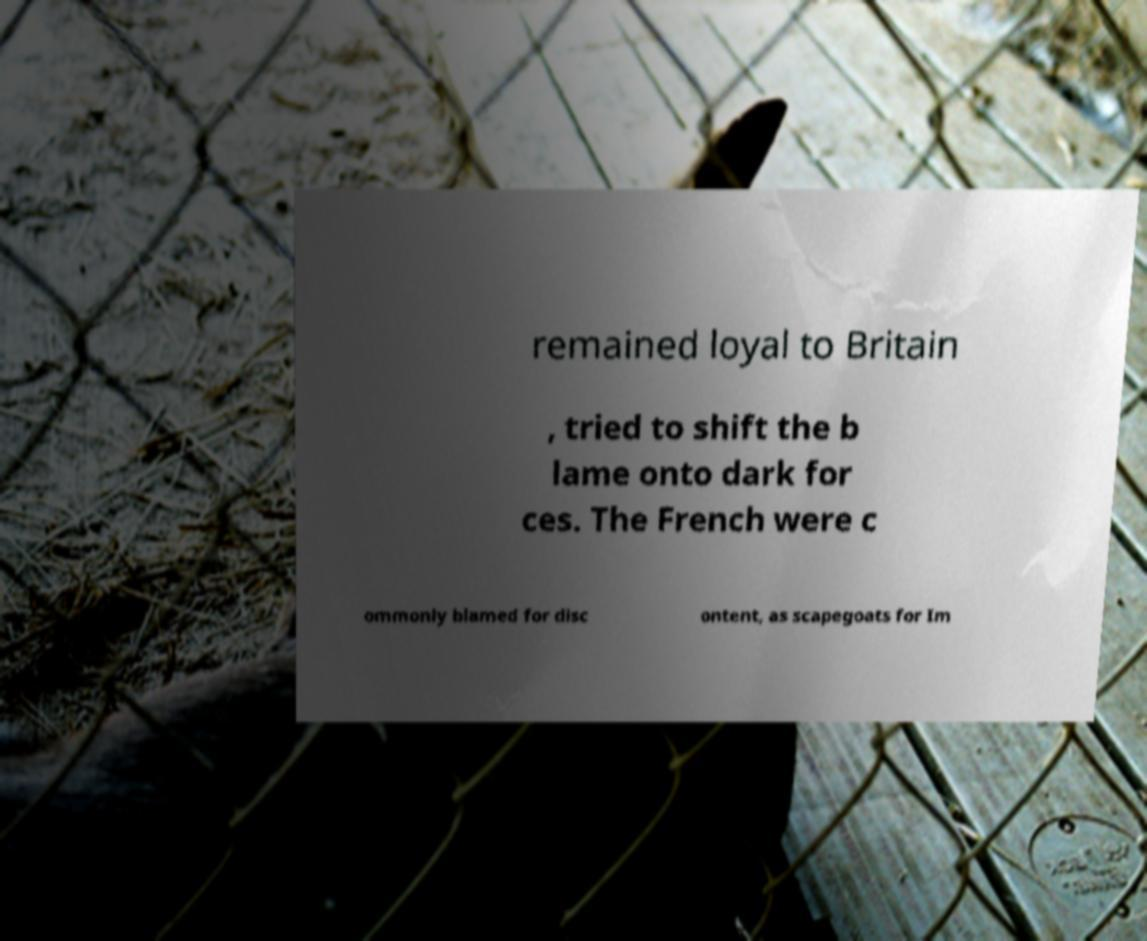Could you assist in decoding the text presented in this image and type it out clearly? remained loyal to Britain , tried to shift the b lame onto dark for ces. The French were c ommonly blamed for disc ontent, as scapegoats for Im 